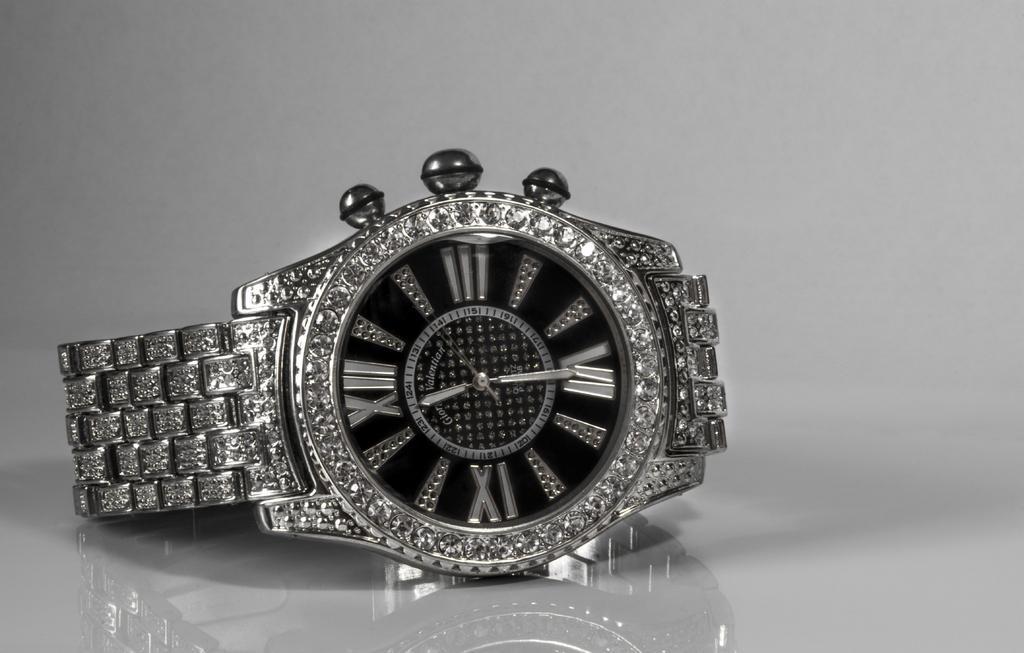In one or two sentences, can you explain what this image depicts? In this image there is a watch. 